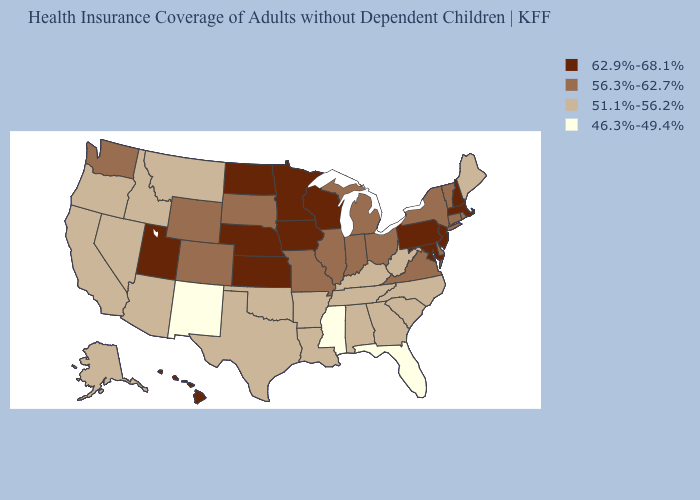What is the lowest value in states that border Wisconsin?
Give a very brief answer. 56.3%-62.7%. Among the states that border Nevada , does California have the lowest value?
Keep it brief. Yes. Name the states that have a value in the range 51.1%-56.2%?
Quick response, please. Alabama, Alaska, Arizona, Arkansas, California, Georgia, Idaho, Kentucky, Louisiana, Maine, Montana, Nevada, North Carolina, Oklahoma, Oregon, South Carolina, Tennessee, Texas, West Virginia. What is the value of Idaho?
Concise answer only. 51.1%-56.2%. What is the value of Mississippi?
Answer briefly. 46.3%-49.4%. Among the states that border Wyoming , does Utah have the lowest value?
Answer briefly. No. Among the states that border Colorado , which have the highest value?
Short answer required. Kansas, Nebraska, Utah. What is the value of Georgia?
Concise answer only. 51.1%-56.2%. Does New Mexico have the lowest value in the USA?
Give a very brief answer. Yes. What is the highest value in states that border Oklahoma?
Concise answer only. 62.9%-68.1%. What is the value of New York?
Short answer required. 56.3%-62.7%. What is the lowest value in the USA?
Concise answer only. 46.3%-49.4%. What is the value of Massachusetts?
Be succinct. 62.9%-68.1%. Which states have the lowest value in the USA?
Concise answer only. Florida, Mississippi, New Mexico. Which states have the lowest value in the USA?
Keep it brief. Florida, Mississippi, New Mexico. 